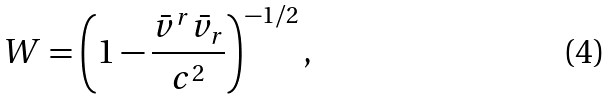Convert formula to latex. <formula><loc_0><loc_0><loc_500><loc_500>W = \left ( 1 - \frac { \bar { v } ^ { r } \bar { v } _ { r } } { c ^ { 2 } } \right ) ^ { - 1 / 2 } ,</formula> 